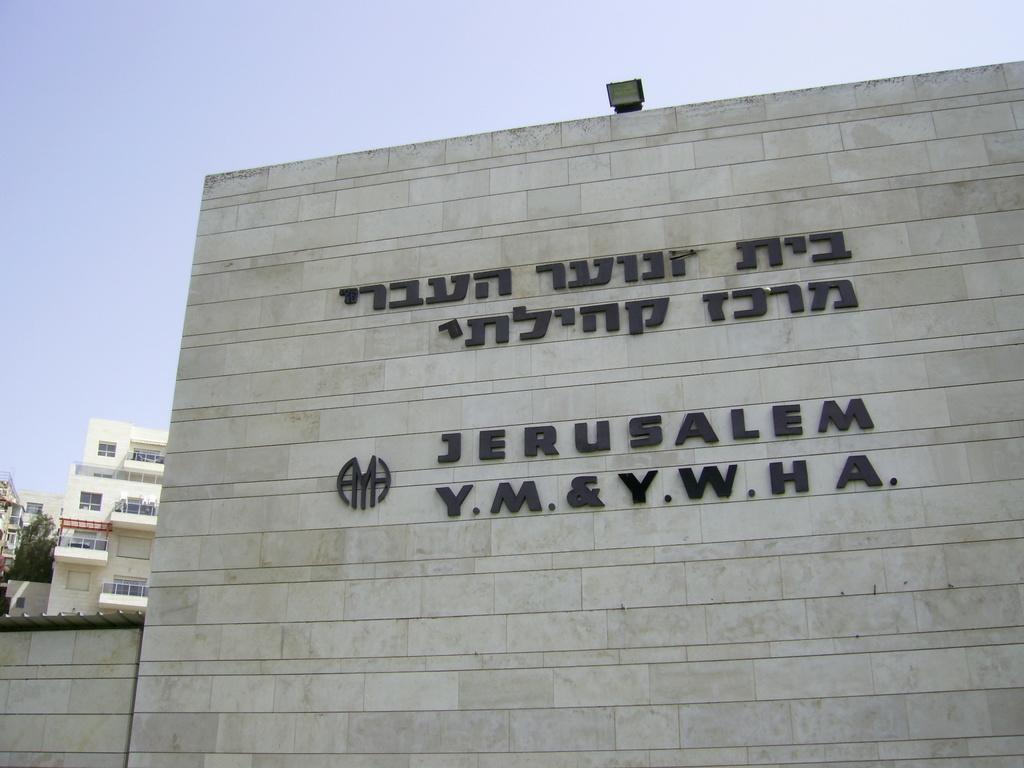Can you describe this image briefly? In the center of the image there is a wall. On wall some text and logo are present. On the left side of the image we can see some buildings, trees are there. At the top of the image we can see a sky and light are present. 